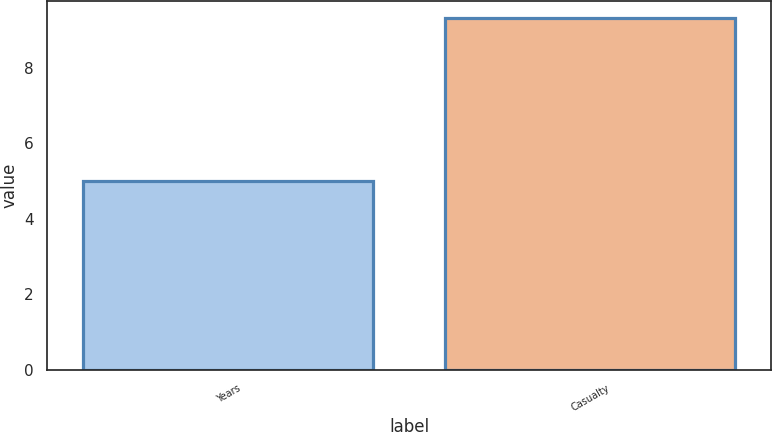<chart> <loc_0><loc_0><loc_500><loc_500><bar_chart><fcel>Years<fcel>Casualty<nl><fcel>5<fcel>9.3<nl></chart> 